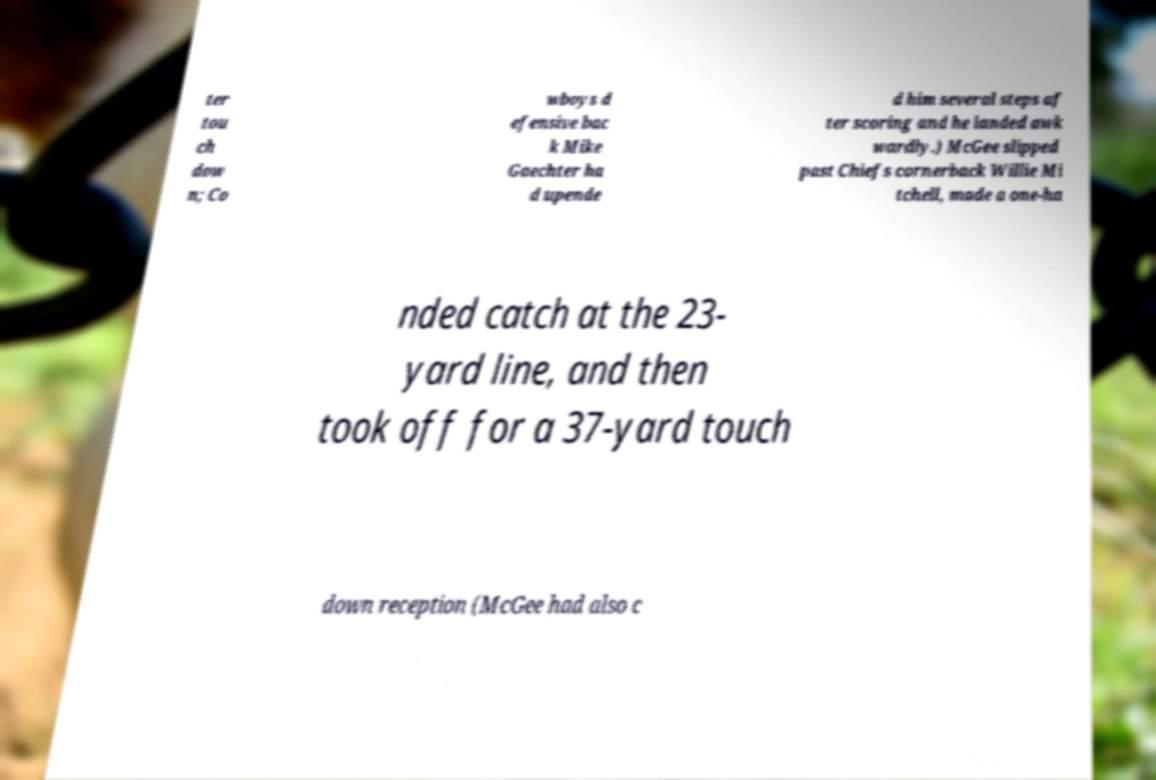Please read and relay the text visible in this image. What does it say? ter tou ch dow n; Co wboys d efensive bac k Mike Gaechter ha d upende d him several steps af ter scoring and he landed awk wardly.) McGee slipped past Chiefs cornerback Willie Mi tchell, made a one-ha nded catch at the 23- yard line, and then took off for a 37-yard touch down reception (McGee had also c 